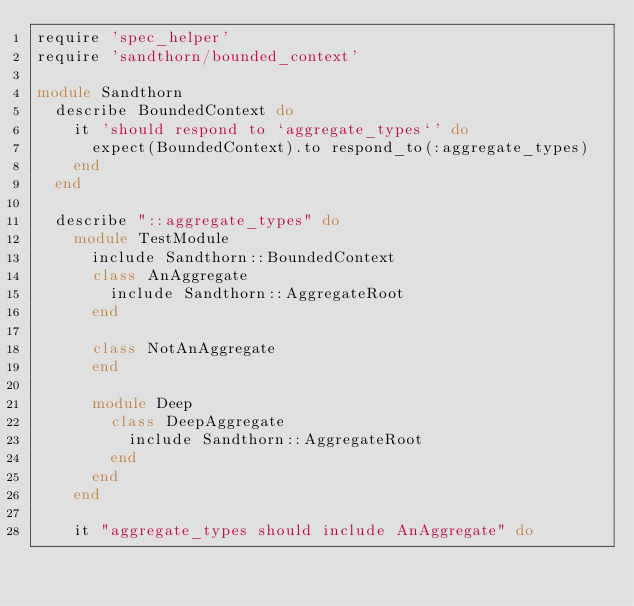<code> <loc_0><loc_0><loc_500><loc_500><_Ruby_>require 'spec_helper'
require 'sandthorn/bounded_context'

module Sandthorn
  describe BoundedContext do
    it 'should respond to `aggregate_types`' do
      expect(BoundedContext).to respond_to(:aggregate_types)
    end
  end

  describe "::aggregate_types" do
    module TestModule
      include Sandthorn::BoundedContext
      class AnAggregate 
        include Sandthorn::AggregateRoot
      end

      class NotAnAggregate
      end

      module Deep
        class DeepAggregate
          include Sandthorn::AggregateRoot
        end
      end
    end

    it "aggregate_types should include AnAggregate" do</code> 